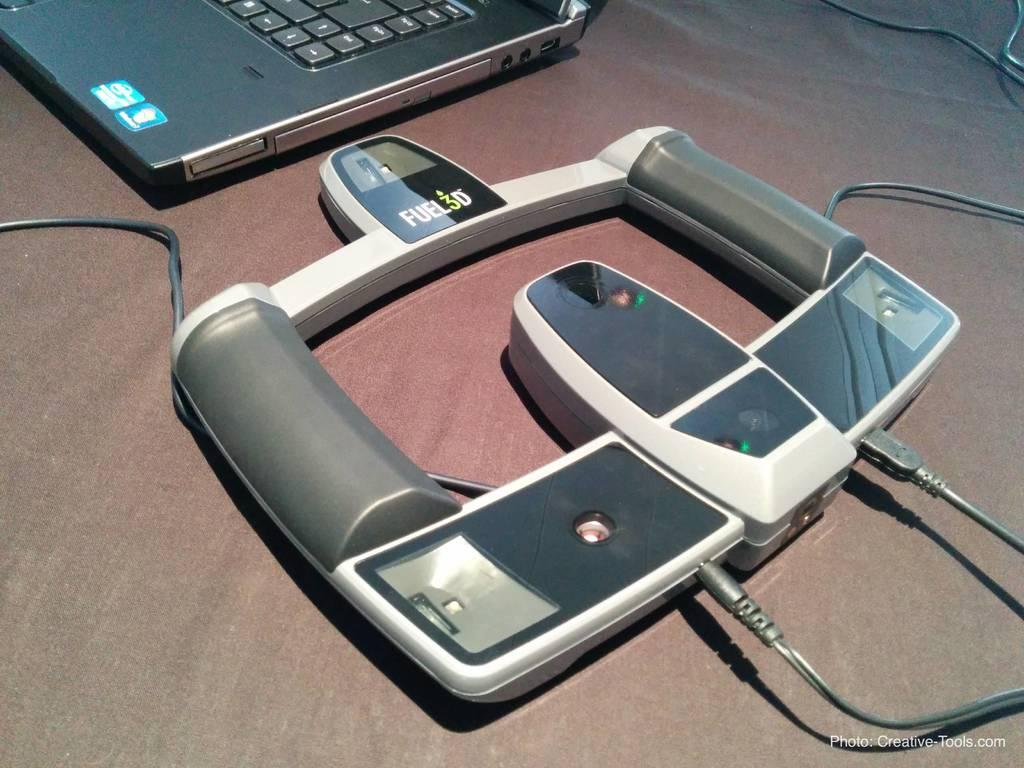What is the main object connected with wires in the image? There is an object connected with wires in the image, but the specific object is not mentioned in the facts. Where is the laptop located in the image? The laptop is in the left top corner of the image. How many ants can be seen crawling on the laptop in the image? There are no ants present in the image; it only features an object connected with wires and a laptop in the left top corner. 